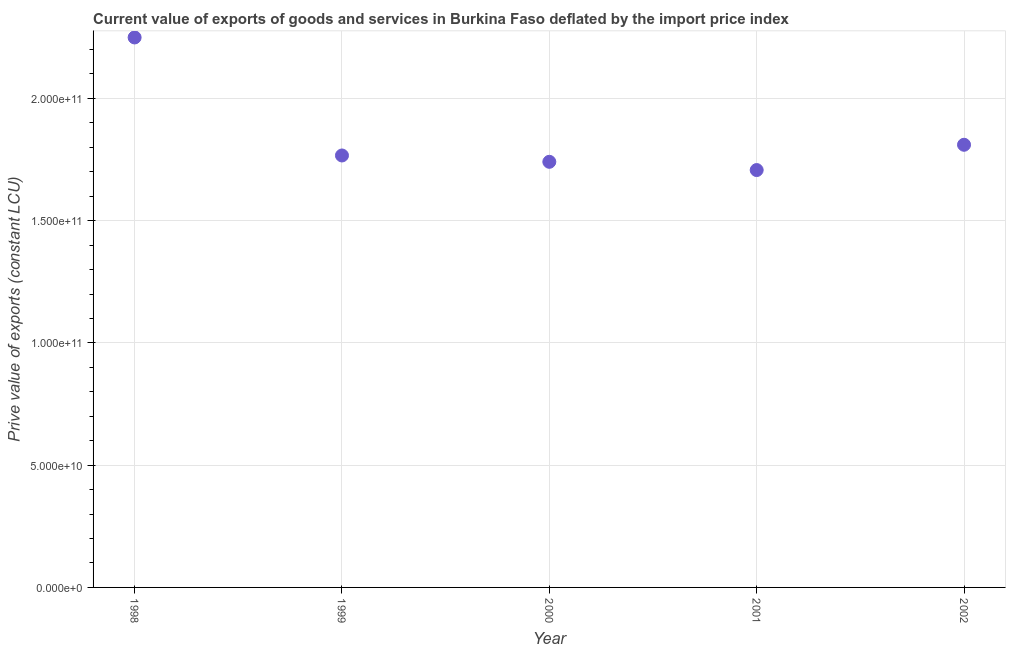What is the price value of exports in 1999?
Provide a short and direct response. 1.77e+11. Across all years, what is the maximum price value of exports?
Ensure brevity in your answer.  2.25e+11. Across all years, what is the minimum price value of exports?
Keep it short and to the point. 1.71e+11. In which year was the price value of exports maximum?
Ensure brevity in your answer.  1998. In which year was the price value of exports minimum?
Provide a succinct answer. 2001. What is the sum of the price value of exports?
Provide a short and direct response. 9.27e+11. What is the difference between the price value of exports in 1998 and 2000?
Provide a short and direct response. 5.09e+1. What is the average price value of exports per year?
Keep it short and to the point. 1.85e+11. What is the median price value of exports?
Your answer should be very brief. 1.77e+11. In how many years, is the price value of exports greater than 60000000000 LCU?
Provide a short and direct response. 5. Do a majority of the years between 2001 and 1998 (inclusive) have price value of exports greater than 30000000000 LCU?
Keep it short and to the point. Yes. What is the ratio of the price value of exports in 1999 to that in 2001?
Offer a terse response. 1.03. Is the price value of exports in 1998 less than that in 2002?
Keep it short and to the point. No. Is the difference between the price value of exports in 1998 and 2000 greater than the difference between any two years?
Your answer should be very brief. No. What is the difference between the highest and the second highest price value of exports?
Provide a short and direct response. 4.39e+1. What is the difference between the highest and the lowest price value of exports?
Ensure brevity in your answer.  5.42e+1. In how many years, is the price value of exports greater than the average price value of exports taken over all years?
Your response must be concise. 1. Does the price value of exports monotonically increase over the years?
Offer a terse response. No. How many dotlines are there?
Give a very brief answer. 1. What is the difference between two consecutive major ticks on the Y-axis?
Your answer should be compact. 5.00e+1. Does the graph contain any zero values?
Your answer should be very brief. No. Does the graph contain grids?
Your answer should be compact. Yes. What is the title of the graph?
Ensure brevity in your answer.  Current value of exports of goods and services in Burkina Faso deflated by the import price index. What is the label or title of the X-axis?
Offer a terse response. Year. What is the label or title of the Y-axis?
Offer a terse response. Prive value of exports (constant LCU). What is the Prive value of exports (constant LCU) in 1998?
Make the answer very short. 2.25e+11. What is the Prive value of exports (constant LCU) in 1999?
Your response must be concise. 1.77e+11. What is the Prive value of exports (constant LCU) in 2000?
Ensure brevity in your answer.  1.74e+11. What is the Prive value of exports (constant LCU) in 2001?
Give a very brief answer. 1.71e+11. What is the Prive value of exports (constant LCU) in 2002?
Provide a short and direct response. 1.81e+11. What is the difference between the Prive value of exports (constant LCU) in 1998 and 1999?
Make the answer very short. 4.83e+1. What is the difference between the Prive value of exports (constant LCU) in 1998 and 2000?
Ensure brevity in your answer.  5.09e+1. What is the difference between the Prive value of exports (constant LCU) in 1998 and 2001?
Your answer should be very brief. 5.42e+1. What is the difference between the Prive value of exports (constant LCU) in 1998 and 2002?
Keep it short and to the point. 4.39e+1. What is the difference between the Prive value of exports (constant LCU) in 1999 and 2000?
Offer a terse response. 2.59e+09. What is the difference between the Prive value of exports (constant LCU) in 1999 and 2001?
Your response must be concise. 5.96e+09. What is the difference between the Prive value of exports (constant LCU) in 1999 and 2002?
Offer a terse response. -4.38e+09. What is the difference between the Prive value of exports (constant LCU) in 2000 and 2001?
Provide a succinct answer. 3.37e+09. What is the difference between the Prive value of exports (constant LCU) in 2000 and 2002?
Your response must be concise. -6.97e+09. What is the difference between the Prive value of exports (constant LCU) in 2001 and 2002?
Make the answer very short. -1.03e+1. What is the ratio of the Prive value of exports (constant LCU) in 1998 to that in 1999?
Your answer should be compact. 1.27. What is the ratio of the Prive value of exports (constant LCU) in 1998 to that in 2000?
Make the answer very short. 1.29. What is the ratio of the Prive value of exports (constant LCU) in 1998 to that in 2001?
Your answer should be very brief. 1.32. What is the ratio of the Prive value of exports (constant LCU) in 1998 to that in 2002?
Keep it short and to the point. 1.24. What is the ratio of the Prive value of exports (constant LCU) in 1999 to that in 2000?
Keep it short and to the point. 1.01. What is the ratio of the Prive value of exports (constant LCU) in 1999 to that in 2001?
Your answer should be compact. 1.03. What is the ratio of the Prive value of exports (constant LCU) in 2000 to that in 2002?
Provide a short and direct response. 0.96. What is the ratio of the Prive value of exports (constant LCU) in 2001 to that in 2002?
Offer a very short reply. 0.94. 